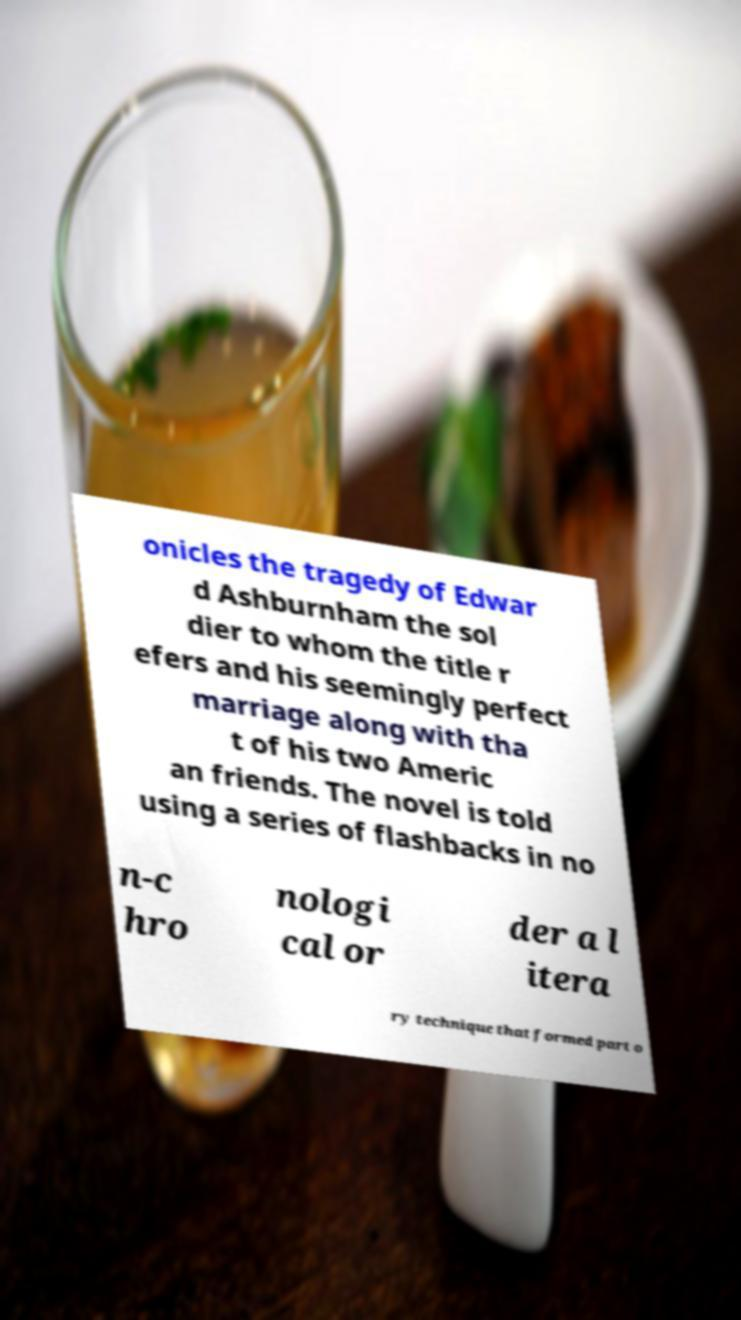I need the written content from this picture converted into text. Can you do that? onicles the tragedy of Edwar d Ashburnham the sol dier to whom the title r efers and his seemingly perfect marriage along with tha t of his two Americ an friends. The novel is told using a series of flashbacks in no n-c hro nologi cal or der a l itera ry technique that formed part o 